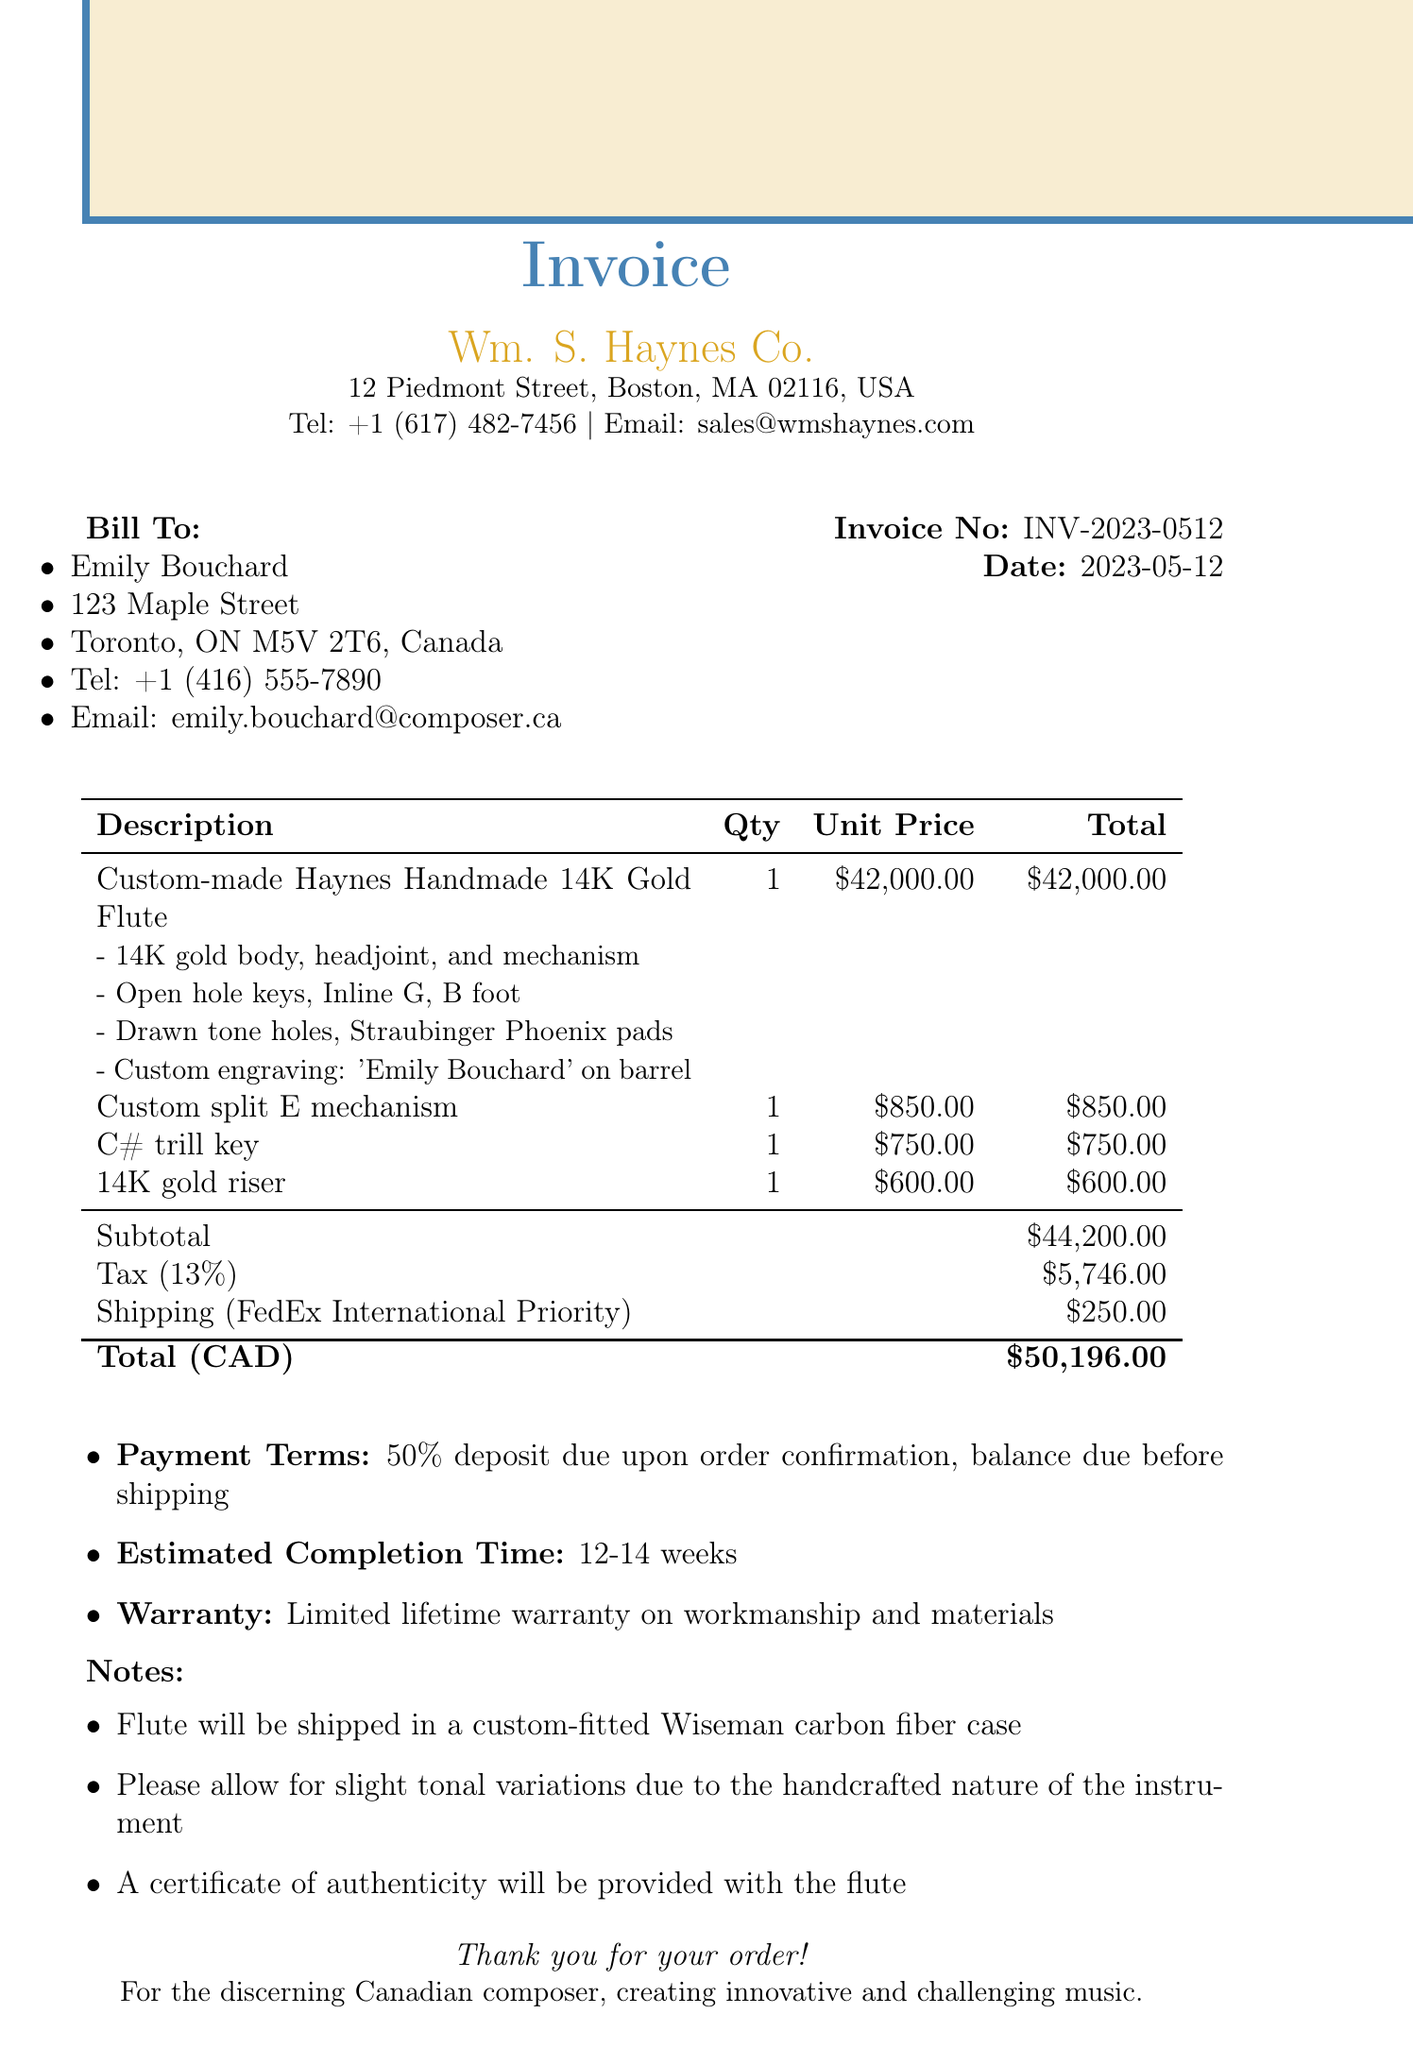What is the invoice number? The invoice number is listed near the top of the document, under the invoice details.
Answer: INV-2023-0512 Who is the buyer? The buyer's name is mentioned in the billing section of the document.
Answer: Emily Bouchard What is the total amount due? The total amount due is calculated at the bottom of the invoice after adding subtotal, tax, and shipping costs.
Answer: $50,196.00 What is the tax rate applied? The tax rate is specified as a percentage in the tax section of the invoice.
Answer: 13% What custom feature is engraved on the flute? The engraving detail is included in the item description for the custom-made flute.
Answer: 'Emily Bouchard' on barrel How long is the estimated completion time? The estimated completion time is provided in a detailed section of the invoice.
Answer: 12-14 weeks What payment terms are outlined in the document? Payment terms are explicitly stated under the payment section of the invoice.
Answer: 50% deposit due upon order confirmation, balance due before shipping What shipping method will be used? The shipping method is mentioned in the shipping section of the document.
Answer: FedEx International Priority What warranty is provided for the flute? The warranty terms are specified in a particular section of the invoice.
Answer: Limited lifetime warranty on workmanship and materials 